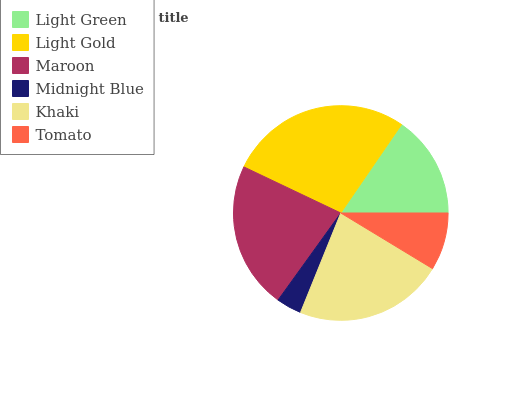Is Midnight Blue the minimum?
Answer yes or no. Yes. Is Light Gold the maximum?
Answer yes or no. Yes. Is Maroon the minimum?
Answer yes or no. No. Is Maroon the maximum?
Answer yes or no. No. Is Light Gold greater than Maroon?
Answer yes or no. Yes. Is Maroon less than Light Gold?
Answer yes or no. Yes. Is Maroon greater than Light Gold?
Answer yes or no. No. Is Light Gold less than Maroon?
Answer yes or no. No. Is Maroon the high median?
Answer yes or no. Yes. Is Light Green the low median?
Answer yes or no. Yes. Is Midnight Blue the high median?
Answer yes or no. No. Is Midnight Blue the low median?
Answer yes or no. No. 